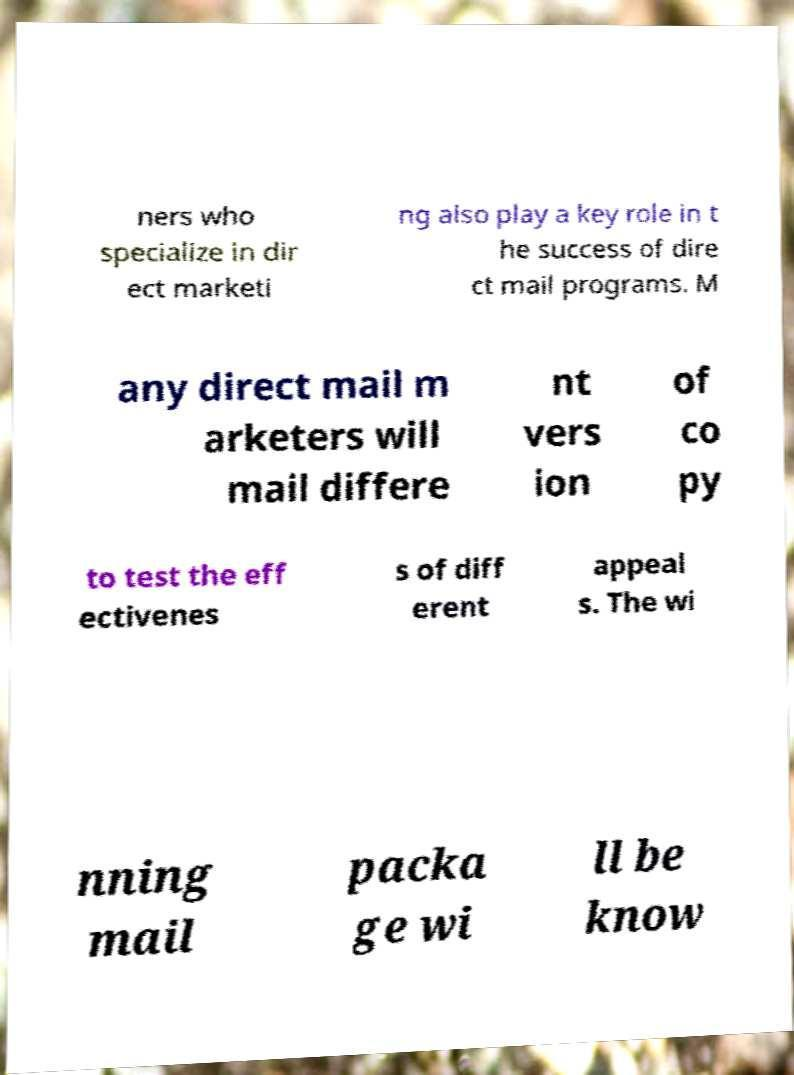For documentation purposes, I need the text within this image transcribed. Could you provide that? ners who specialize in dir ect marketi ng also play a key role in t he success of dire ct mail programs. M any direct mail m arketers will mail differe nt vers ion of co py to test the eff ectivenes s of diff erent appeal s. The wi nning mail packa ge wi ll be know 